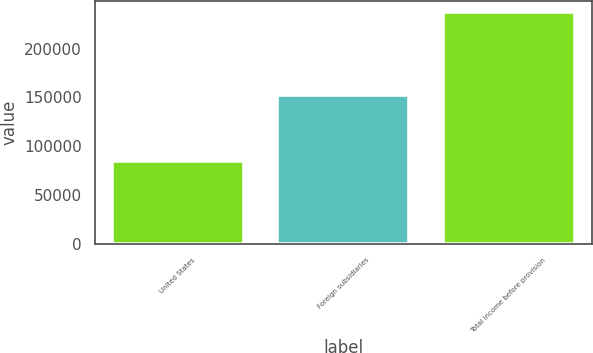Convert chart. <chart><loc_0><loc_0><loc_500><loc_500><bar_chart><fcel>United States<fcel>Foreign subsidiaries<fcel>Total income before provision<nl><fcel>84694<fcel>152459<fcel>237153<nl></chart> 